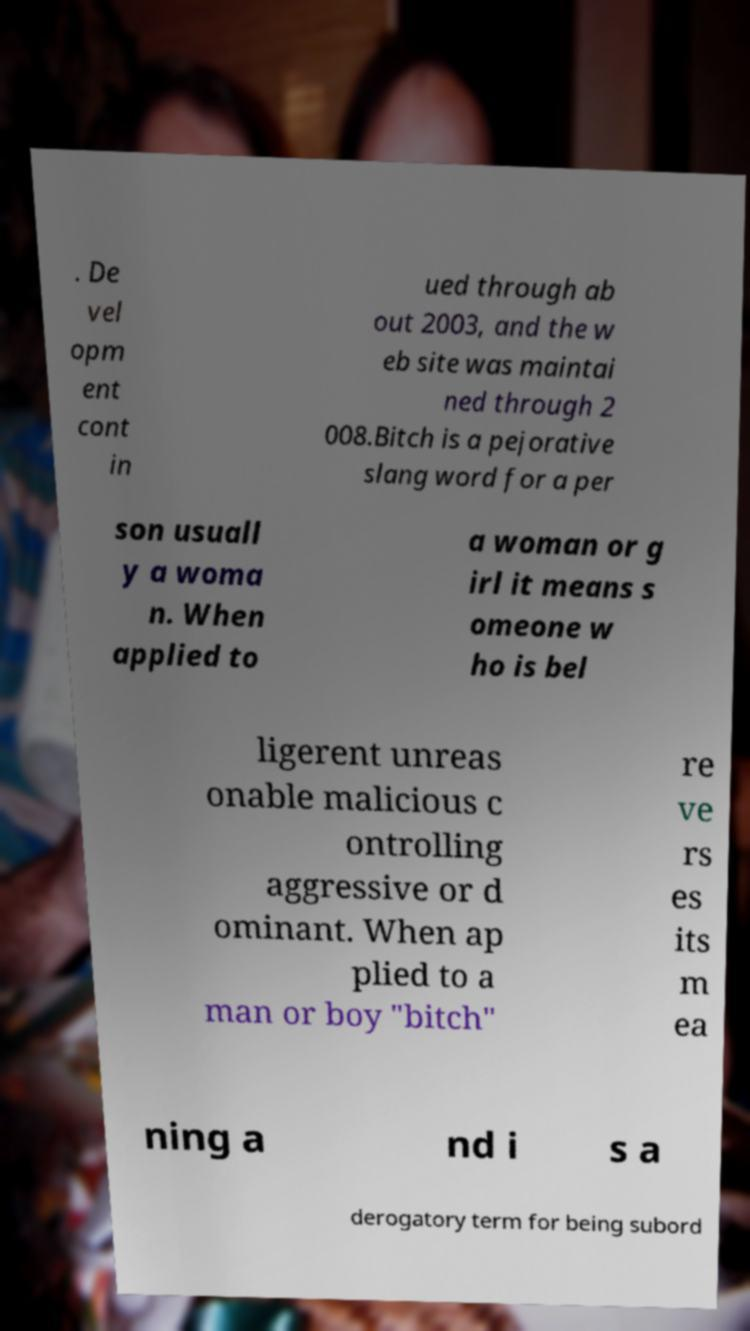Could you extract and type out the text from this image? . De vel opm ent cont in ued through ab out 2003, and the w eb site was maintai ned through 2 008.Bitch is a pejorative slang word for a per son usuall y a woma n. When applied to a woman or g irl it means s omeone w ho is bel ligerent unreas onable malicious c ontrolling aggressive or d ominant. When ap plied to a man or boy "bitch" re ve rs es its m ea ning a nd i s a derogatory term for being subord 